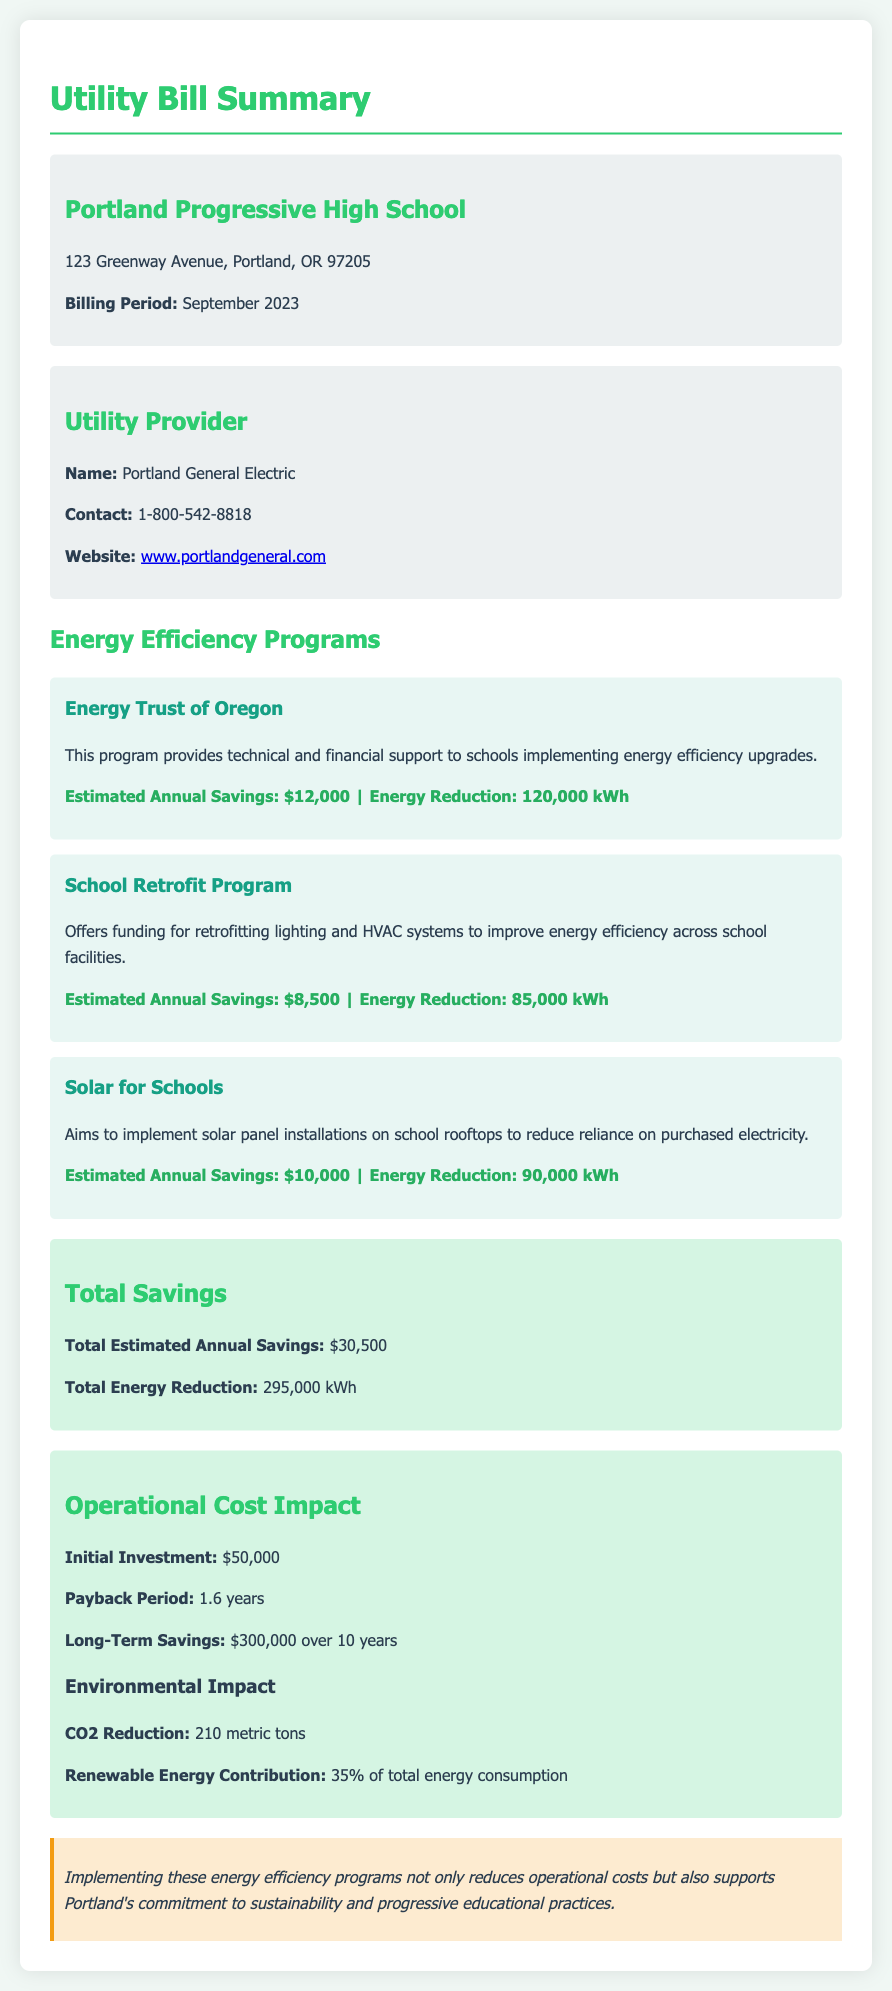What is the name of the utility provider? The utility provider's name is provided in the document under the utility provider section.
Answer: Portland General Electric What is the estimated annual savings from the Energy Trust of Oregon program? The estimated annual savings from the Energy Trust of Oregon program is specified in the program's details.
Answer: $12,000 What is the total estimated annual savings from all programs? The total estimated annual savings is summarized under the total savings section of the document.
Answer: $30,500 What is the payback period for the energy efficiency programs? The payback period is stated in the operational cost impact section of the document.
Answer: 1.6 years What is the CO2 reduction achieved through these programs? The CO2 reduction figure is provided in the environmental impact subsection of the operational cost impact section.
Answer: 210 metric tons What is the initial investment required for the energy efficiency programs? The initial investment amount is mentioned in the operational cost impact section of the document.
Answer: $50,000 What percentage of total energy consumption is contributed by renewable energy? The renewable energy contribution percentage is noted in the environmental impact section of the document.
Answer: 35% What is the energy reduction from the School Retrofit Program? The energy reduction for the School Retrofit Program is listed in its program details.
Answer: 85,000 kWh What is the total energy reduction from all programs? The total energy reduction is concluded in the total savings section of the document.
Answer: 295,000 kWh 